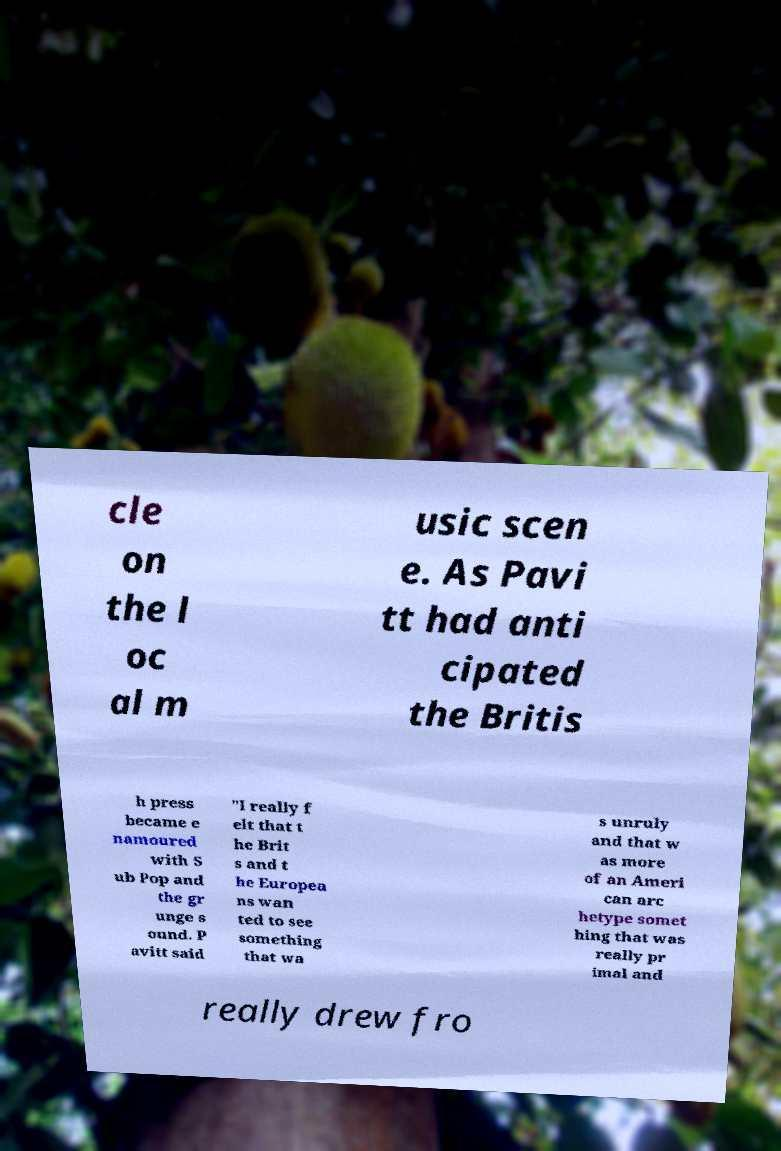Could you extract and type out the text from this image? cle on the l oc al m usic scen e. As Pavi tt had anti cipated the Britis h press became e namoured with S ub Pop and the gr unge s ound. P avitt said "I really f elt that t he Brit s and t he Europea ns wan ted to see something that wa s unruly and that w as more of an Ameri can arc hetype somet hing that was really pr imal and really drew fro 